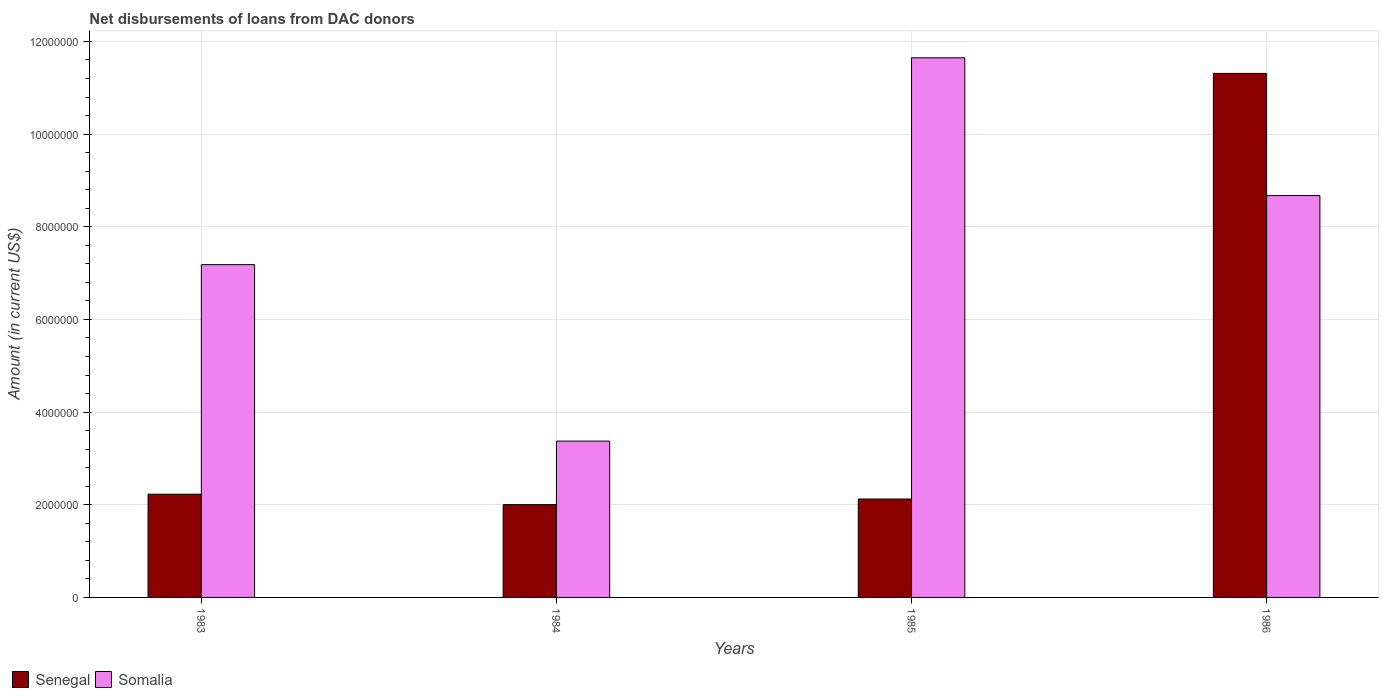How many different coloured bars are there?
Your answer should be compact. 2. How many groups of bars are there?
Your answer should be compact. 4. How many bars are there on the 4th tick from the right?
Your answer should be compact. 2. In how many cases, is the number of bars for a given year not equal to the number of legend labels?
Offer a terse response. 0. What is the amount of loans disbursed in Somalia in 1983?
Keep it short and to the point. 7.18e+06. Across all years, what is the maximum amount of loans disbursed in Somalia?
Offer a very short reply. 1.16e+07. Across all years, what is the minimum amount of loans disbursed in Somalia?
Provide a short and direct response. 3.37e+06. In which year was the amount of loans disbursed in Somalia maximum?
Your response must be concise. 1985. What is the total amount of loans disbursed in Somalia in the graph?
Your answer should be compact. 3.09e+07. What is the difference between the amount of loans disbursed in Somalia in 1985 and that in 1986?
Provide a short and direct response. 2.97e+06. What is the difference between the amount of loans disbursed in Senegal in 1986 and the amount of loans disbursed in Somalia in 1983?
Your answer should be compact. 4.13e+06. What is the average amount of loans disbursed in Senegal per year?
Keep it short and to the point. 4.42e+06. In the year 1984, what is the difference between the amount of loans disbursed in Somalia and amount of loans disbursed in Senegal?
Provide a short and direct response. 1.37e+06. In how many years, is the amount of loans disbursed in Senegal greater than 9200000 US$?
Your response must be concise. 1. What is the ratio of the amount of loans disbursed in Senegal in 1984 to that in 1985?
Offer a very short reply. 0.94. Is the amount of loans disbursed in Somalia in 1985 less than that in 1986?
Offer a terse response. No. What is the difference between the highest and the second highest amount of loans disbursed in Somalia?
Give a very brief answer. 2.97e+06. What is the difference between the highest and the lowest amount of loans disbursed in Senegal?
Your answer should be very brief. 9.31e+06. What does the 1st bar from the left in 1983 represents?
Keep it short and to the point. Senegal. What does the 1st bar from the right in 1985 represents?
Keep it short and to the point. Somalia. Are the values on the major ticks of Y-axis written in scientific E-notation?
Your answer should be compact. No. Does the graph contain grids?
Give a very brief answer. Yes. Where does the legend appear in the graph?
Offer a terse response. Bottom left. How are the legend labels stacked?
Ensure brevity in your answer.  Horizontal. What is the title of the graph?
Ensure brevity in your answer.  Net disbursements of loans from DAC donors. Does "Saudi Arabia" appear as one of the legend labels in the graph?
Provide a short and direct response. No. What is the label or title of the Y-axis?
Provide a short and direct response. Amount (in current US$). What is the Amount (in current US$) in Senegal in 1983?
Ensure brevity in your answer.  2.23e+06. What is the Amount (in current US$) of Somalia in 1983?
Keep it short and to the point. 7.18e+06. What is the Amount (in current US$) in Senegal in 1984?
Your answer should be compact. 2.00e+06. What is the Amount (in current US$) in Somalia in 1984?
Keep it short and to the point. 3.37e+06. What is the Amount (in current US$) of Senegal in 1985?
Your answer should be compact. 2.12e+06. What is the Amount (in current US$) of Somalia in 1985?
Offer a terse response. 1.16e+07. What is the Amount (in current US$) of Senegal in 1986?
Provide a succinct answer. 1.13e+07. What is the Amount (in current US$) in Somalia in 1986?
Provide a succinct answer. 8.67e+06. Across all years, what is the maximum Amount (in current US$) in Senegal?
Provide a succinct answer. 1.13e+07. Across all years, what is the maximum Amount (in current US$) of Somalia?
Make the answer very short. 1.16e+07. Across all years, what is the minimum Amount (in current US$) of Senegal?
Your answer should be compact. 2.00e+06. Across all years, what is the minimum Amount (in current US$) of Somalia?
Your answer should be compact. 3.37e+06. What is the total Amount (in current US$) of Senegal in the graph?
Your answer should be compact. 1.77e+07. What is the total Amount (in current US$) of Somalia in the graph?
Your answer should be compact. 3.09e+07. What is the difference between the Amount (in current US$) in Senegal in 1983 and that in 1984?
Give a very brief answer. 2.25e+05. What is the difference between the Amount (in current US$) in Somalia in 1983 and that in 1984?
Your response must be concise. 3.81e+06. What is the difference between the Amount (in current US$) in Senegal in 1983 and that in 1985?
Provide a short and direct response. 1.04e+05. What is the difference between the Amount (in current US$) of Somalia in 1983 and that in 1985?
Provide a succinct answer. -4.46e+06. What is the difference between the Amount (in current US$) in Senegal in 1983 and that in 1986?
Provide a short and direct response. -9.08e+06. What is the difference between the Amount (in current US$) of Somalia in 1983 and that in 1986?
Provide a succinct answer. -1.49e+06. What is the difference between the Amount (in current US$) of Senegal in 1984 and that in 1985?
Offer a very short reply. -1.21e+05. What is the difference between the Amount (in current US$) of Somalia in 1984 and that in 1985?
Ensure brevity in your answer.  -8.27e+06. What is the difference between the Amount (in current US$) in Senegal in 1984 and that in 1986?
Give a very brief answer. -9.31e+06. What is the difference between the Amount (in current US$) in Somalia in 1984 and that in 1986?
Keep it short and to the point. -5.30e+06. What is the difference between the Amount (in current US$) of Senegal in 1985 and that in 1986?
Make the answer very short. -9.19e+06. What is the difference between the Amount (in current US$) in Somalia in 1985 and that in 1986?
Give a very brief answer. 2.97e+06. What is the difference between the Amount (in current US$) of Senegal in 1983 and the Amount (in current US$) of Somalia in 1984?
Provide a short and direct response. -1.15e+06. What is the difference between the Amount (in current US$) of Senegal in 1983 and the Amount (in current US$) of Somalia in 1985?
Ensure brevity in your answer.  -9.42e+06. What is the difference between the Amount (in current US$) in Senegal in 1983 and the Amount (in current US$) in Somalia in 1986?
Provide a short and direct response. -6.45e+06. What is the difference between the Amount (in current US$) in Senegal in 1984 and the Amount (in current US$) in Somalia in 1985?
Provide a succinct answer. -9.64e+06. What is the difference between the Amount (in current US$) of Senegal in 1984 and the Amount (in current US$) of Somalia in 1986?
Provide a succinct answer. -6.67e+06. What is the difference between the Amount (in current US$) of Senegal in 1985 and the Amount (in current US$) of Somalia in 1986?
Provide a short and direct response. -6.55e+06. What is the average Amount (in current US$) of Senegal per year?
Your response must be concise. 4.42e+06. What is the average Amount (in current US$) in Somalia per year?
Provide a succinct answer. 7.72e+06. In the year 1983, what is the difference between the Amount (in current US$) in Senegal and Amount (in current US$) in Somalia?
Your response must be concise. -4.96e+06. In the year 1984, what is the difference between the Amount (in current US$) of Senegal and Amount (in current US$) of Somalia?
Provide a succinct answer. -1.37e+06. In the year 1985, what is the difference between the Amount (in current US$) of Senegal and Amount (in current US$) of Somalia?
Your response must be concise. -9.52e+06. In the year 1986, what is the difference between the Amount (in current US$) of Senegal and Amount (in current US$) of Somalia?
Offer a terse response. 2.64e+06. What is the ratio of the Amount (in current US$) in Senegal in 1983 to that in 1984?
Keep it short and to the point. 1.11. What is the ratio of the Amount (in current US$) of Somalia in 1983 to that in 1984?
Ensure brevity in your answer.  2.13. What is the ratio of the Amount (in current US$) of Senegal in 1983 to that in 1985?
Ensure brevity in your answer.  1.05. What is the ratio of the Amount (in current US$) of Somalia in 1983 to that in 1985?
Provide a short and direct response. 0.62. What is the ratio of the Amount (in current US$) in Senegal in 1983 to that in 1986?
Make the answer very short. 0.2. What is the ratio of the Amount (in current US$) in Somalia in 1983 to that in 1986?
Your answer should be compact. 0.83. What is the ratio of the Amount (in current US$) of Senegal in 1984 to that in 1985?
Your answer should be very brief. 0.94. What is the ratio of the Amount (in current US$) in Somalia in 1984 to that in 1985?
Make the answer very short. 0.29. What is the ratio of the Amount (in current US$) in Senegal in 1984 to that in 1986?
Offer a very short reply. 0.18. What is the ratio of the Amount (in current US$) in Somalia in 1984 to that in 1986?
Your answer should be very brief. 0.39. What is the ratio of the Amount (in current US$) in Senegal in 1985 to that in 1986?
Make the answer very short. 0.19. What is the ratio of the Amount (in current US$) of Somalia in 1985 to that in 1986?
Ensure brevity in your answer.  1.34. What is the difference between the highest and the second highest Amount (in current US$) of Senegal?
Offer a very short reply. 9.08e+06. What is the difference between the highest and the second highest Amount (in current US$) of Somalia?
Provide a short and direct response. 2.97e+06. What is the difference between the highest and the lowest Amount (in current US$) in Senegal?
Keep it short and to the point. 9.31e+06. What is the difference between the highest and the lowest Amount (in current US$) in Somalia?
Your answer should be compact. 8.27e+06. 